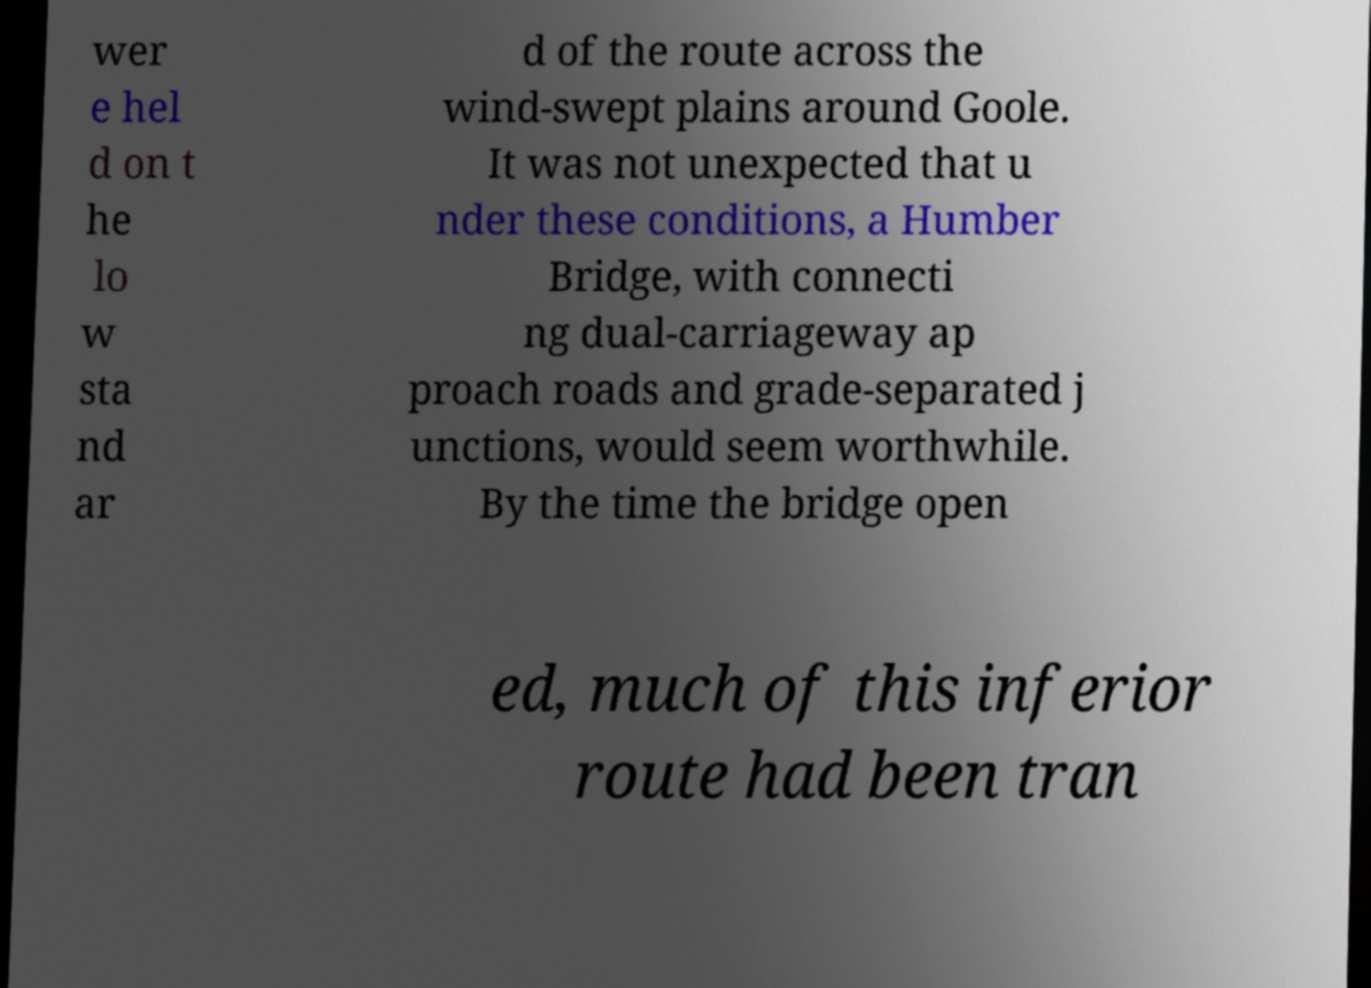For documentation purposes, I need the text within this image transcribed. Could you provide that? wer e hel d on t he lo w sta nd ar d of the route across the wind-swept plains around Goole. It was not unexpected that u nder these conditions, a Humber Bridge, with connecti ng dual-carriageway ap proach roads and grade-separated j unctions, would seem worthwhile. By the time the bridge open ed, much of this inferior route had been tran 